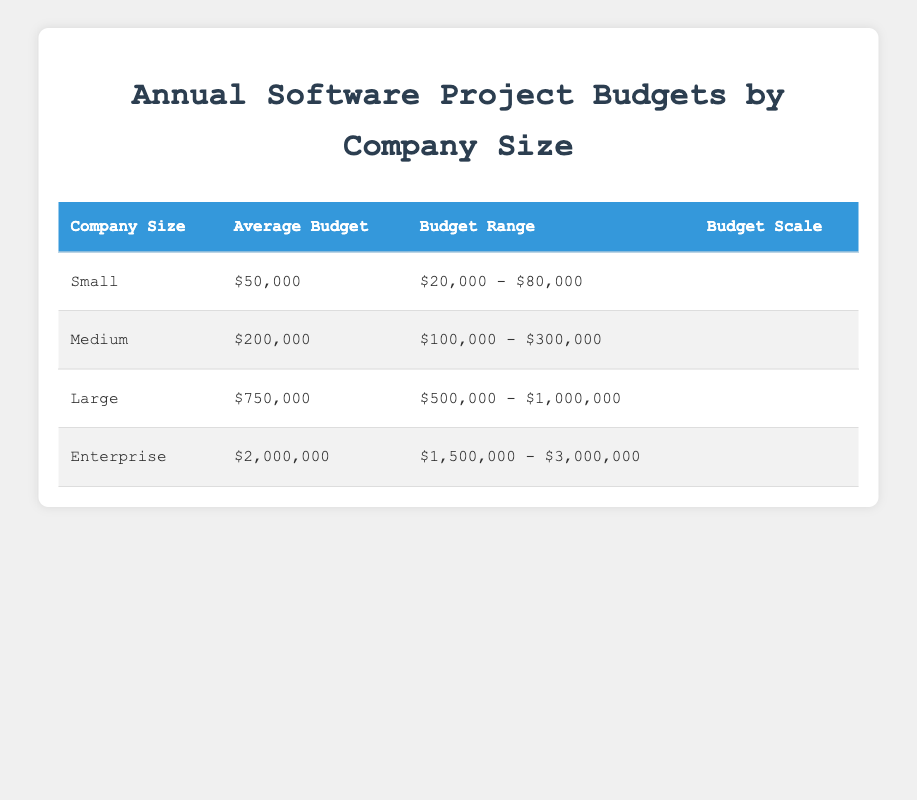What is the average budget for small companies? The average budget for small companies is provided directly in the table under the "Average Budget" column for the "Small" row. It is listed as $50,000.
Answer: $50,000 What is the budget range for medium-sized companies? The budget range for medium-sized companies is found under the "Budget Range" column for the "Medium" row, which is $100,000 - $300,000.
Answer: $100,000 - $300,000 Which company size has the highest average budget? By comparing the average budgets in the "Average Budget" column, it is clear that "Enterprise," with an average budget of $2,000,000, has the highest value among all company sizes listed.
Answer: Enterprise What is the total average budget for all company sizes combined? To find the total average budget, we add the average budgets of all company sizes: $50,000 (Small) + $200,000 (Medium) + $750,000 (Large) + $2,000,000 (Enterprise) = $3,000,000. Then divide by the number of company sizes (4). So, $3,000,000 / 4 = $750,000.
Answer: $750,000 Is the maximum budget for large companies greater than the average budget for medium companies? The maximum budget for large companies is $1,000,000, as stated in the "Budget Range" under the "Large" row, while the average budget for medium companies is $200,000. Comparing these, $1,000,000 is greater than $200,000, thus the statement is true.
Answer: Yes What percentage of their budget do small companies typically allocate when compared to the maximum budget of enterprise-level companies? The average budget for small companies is $50,000, and the maximum budget for enterprise companies is $3,000,000. The percentage is calculated as ($50,000 / $3,000,000) * 100 = 1.67%.
Answer: 1.67% Are there any companies with an average budget of less than $100,000? Reviewing the "Average Budget" column, small companies have an average budget of $50,000, which is less than $100,000, confirming there is at least one company that meets this criterion.
Answer: Yes What is the difference between the minimum budget of small companies and the maximum budget of large companies? The minimum budget for small companies is $20,000, and the maximum budget for large companies is $1,000,000. Therefore, the difference is $1,000,000 - $20,000 = $980,000.
Answer: $980,000 How does the average budget of large companies compare to that of medium companies? The average budget for large companies is $750,000, while for medium companies it is $200,000. Since $750,000 is higher than $200,000, large companies allocate significantly more on average compared to medium companies.
Answer: Higher 